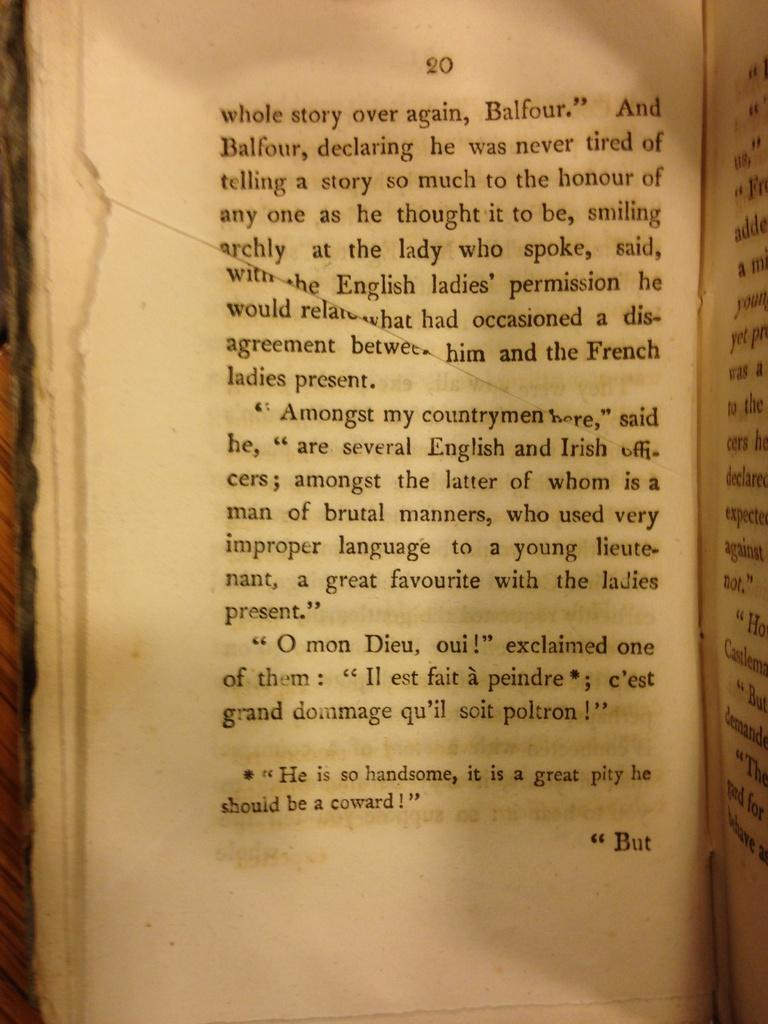Provide a one-sentence caption for the provided image. Page 20 of an old book, describing a character named Balfour. 